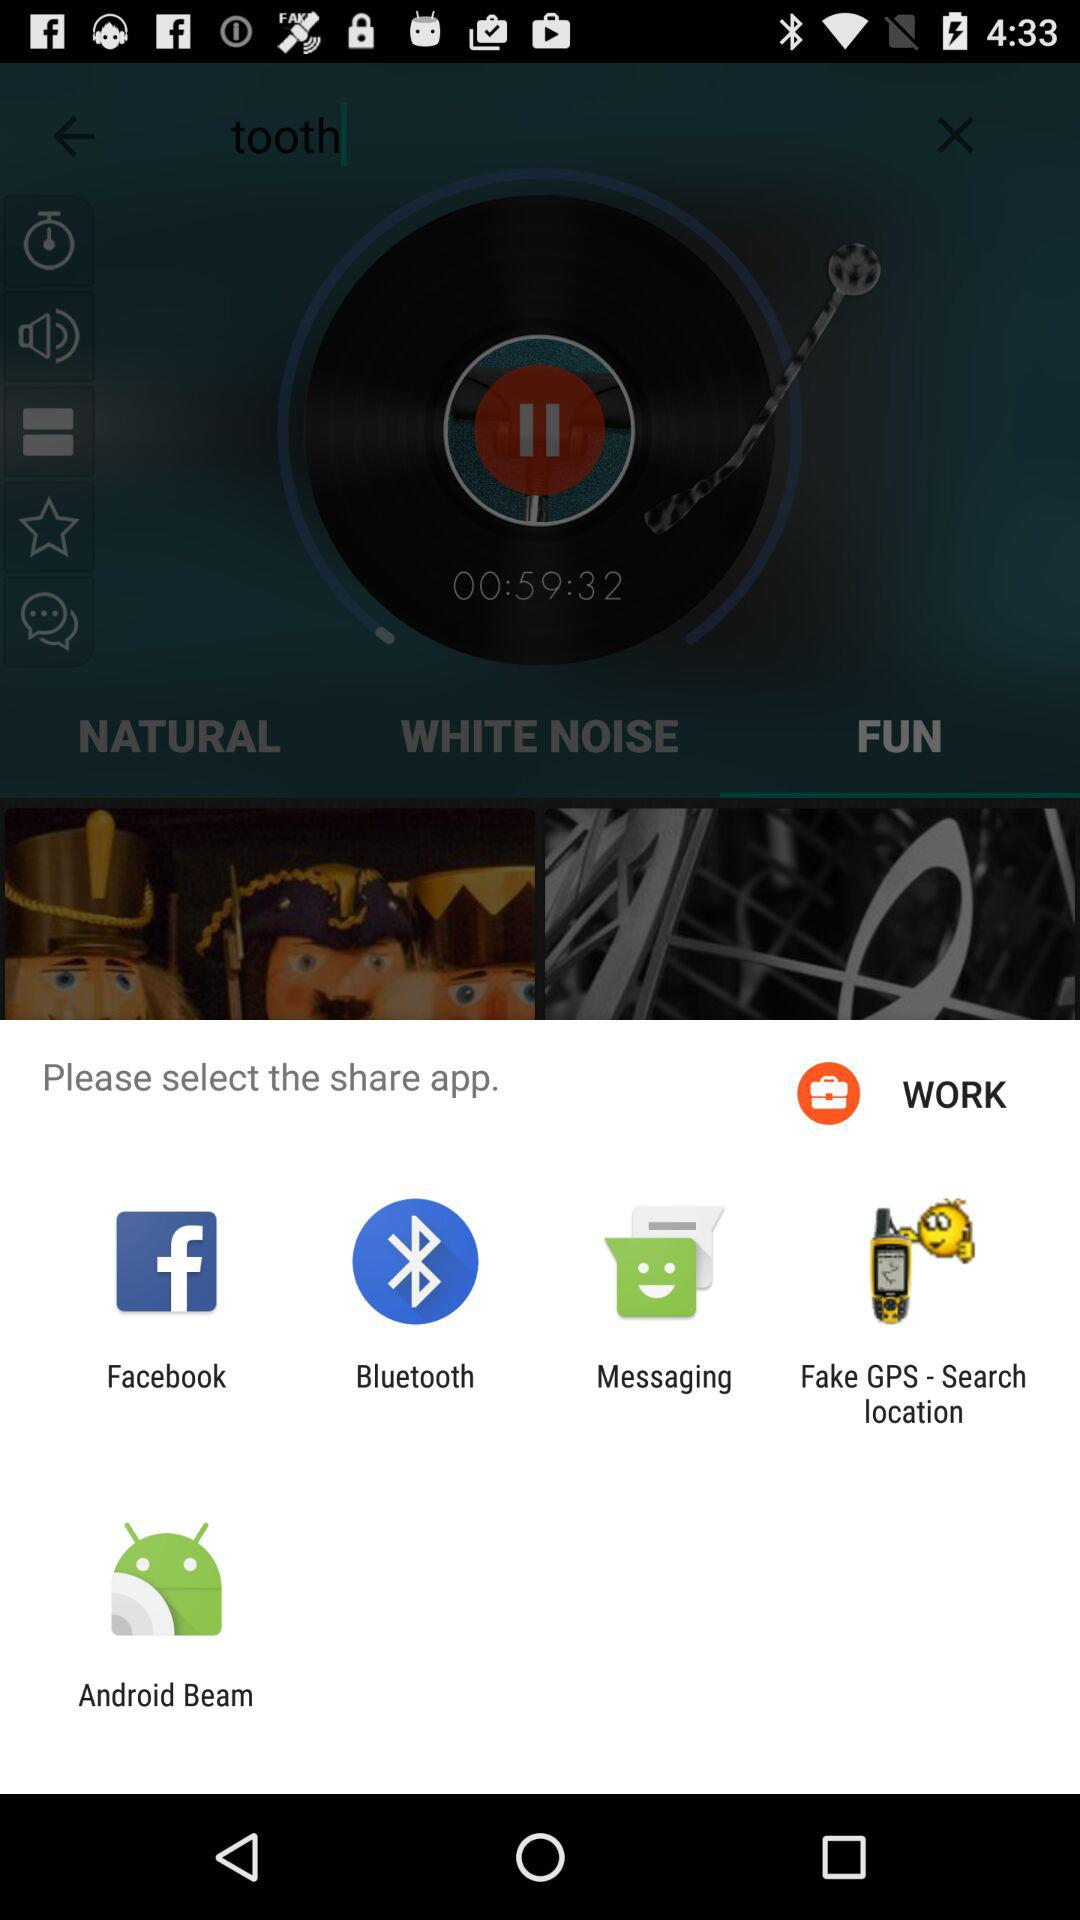Through what app can we share? We can share with "Facebook", "Bluetooth", "Messaging", "Fake GPS - Search location" and "Android Beam". 